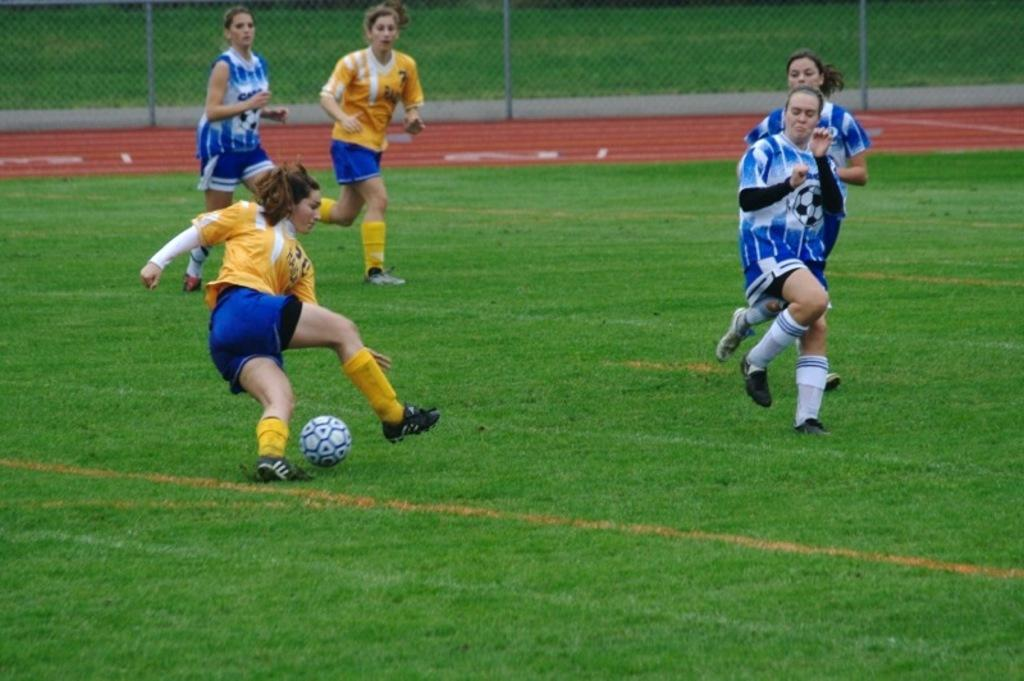What are the persons in the image doing? The persons in the image are playing on the ground. What is the surface they are playing on? The ground is covered with grass. What object is involved in their play? There is a ball present. What can be seen in the background of the image? There is a mesh visible in the background. What type of organization is responsible for the aftermath of the game in the image? There is no game or aftermath depicted in the image, and no organization is mentioned or implied. How many dimes can be seen scattered on the grass in the image? There are no dimes present in the image; it only features persons playing, a ball, and a mesh in the background. 